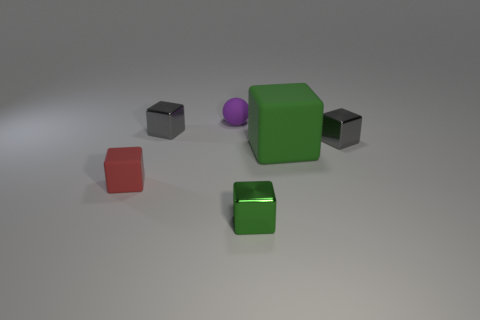Subtract 2 blocks. How many blocks are left? 3 Subtract all green rubber cubes. How many cubes are left? 4 Subtract all red cubes. How many cubes are left? 4 Subtract all cyan blocks. Subtract all yellow spheres. How many blocks are left? 5 Add 1 large purple metal cylinders. How many objects exist? 7 Subtract all cubes. How many objects are left? 1 Add 5 gray shiny cubes. How many gray shiny cubes are left? 7 Add 2 big cyan spheres. How many big cyan spheres exist? 2 Subtract 0 yellow blocks. How many objects are left? 6 Subtract all green shiny things. Subtract all metal blocks. How many objects are left? 2 